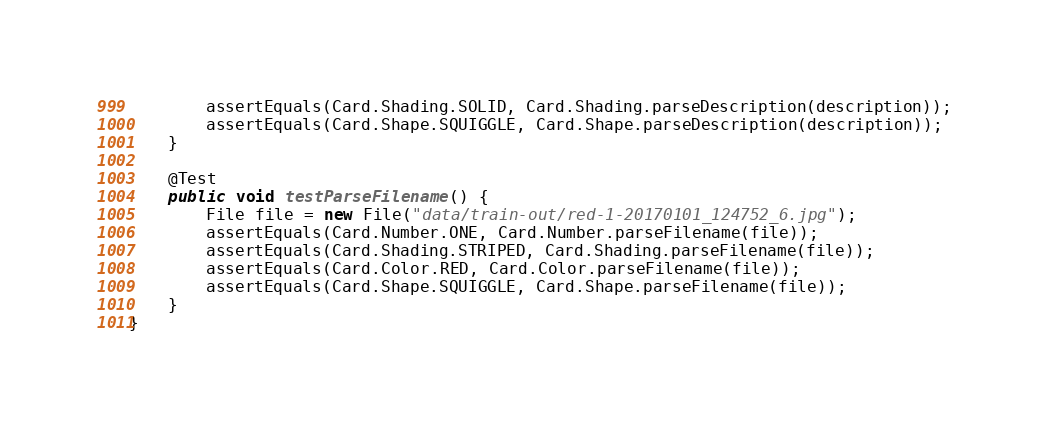Convert code to text. <code><loc_0><loc_0><loc_500><loc_500><_Java_>        assertEquals(Card.Shading.SOLID, Card.Shading.parseDescription(description));
        assertEquals(Card.Shape.SQUIGGLE, Card.Shape.parseDescription(description));
    }

    @Test
    public void testParseFilename() {
        File file = new File("data/train-out/red-1-20170101_124752_6.jpg");
        assertEquals(Card.Number.ONE, Card.Number.parseFilename(file));
        assertEquals(Card.Shading.STRIPED, Card.Shading.parseFilename(file));
        assertEquals(Card.Color.RED, Card.Color.parseFilename(file));
        assertEquals(Card.Shape.SQUIGGLE, Card.Shape.parseFilename(file));
    }
}
</code> 